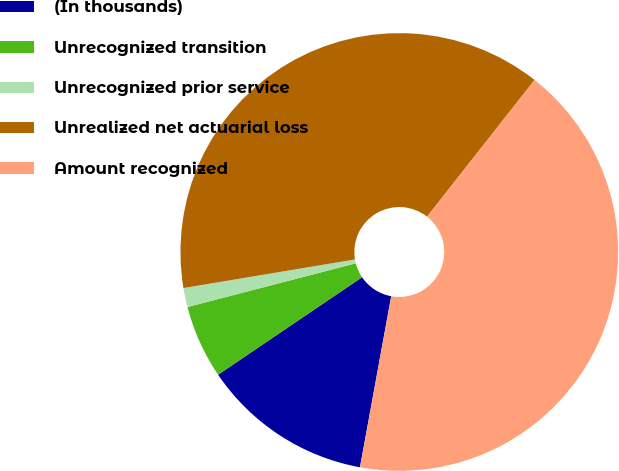<chart> <loc_0><loc_0><loc_500><loc_500><pie_chart><fcel>(In thousands)<fcel>Unrecognized transition<fcel>Unrecognized prior service<fcel>Unrealized net actuarial loss<fcel>Amount recognized<nl><fcel>12.65%<fcel>5.43%<fcel>1.41%<fcel>38.24%<fcel>42.27%<nl></chart> 